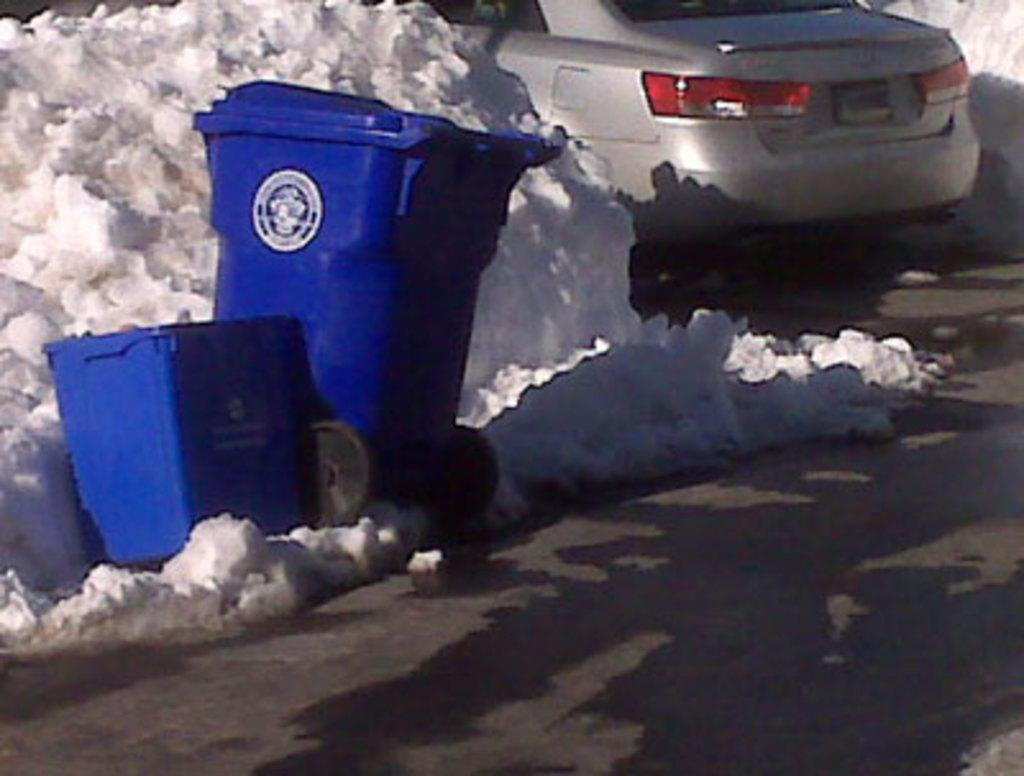What type of containers are visible in the image? There are dustbin boxes in the image. What else can be seen in the image besides the dustbin boxes? There is a vehicle in the image. What is the condition of the road in the image? Snow is present on the road in the image. Can you see a snail crawling on the vehicle in the image? There is no snail visible on the vehicle in the image. Are there any cobwebs present in the image? There is no mention of cobwebs in the provided facts, so we cannot determine if they are present in the image. 